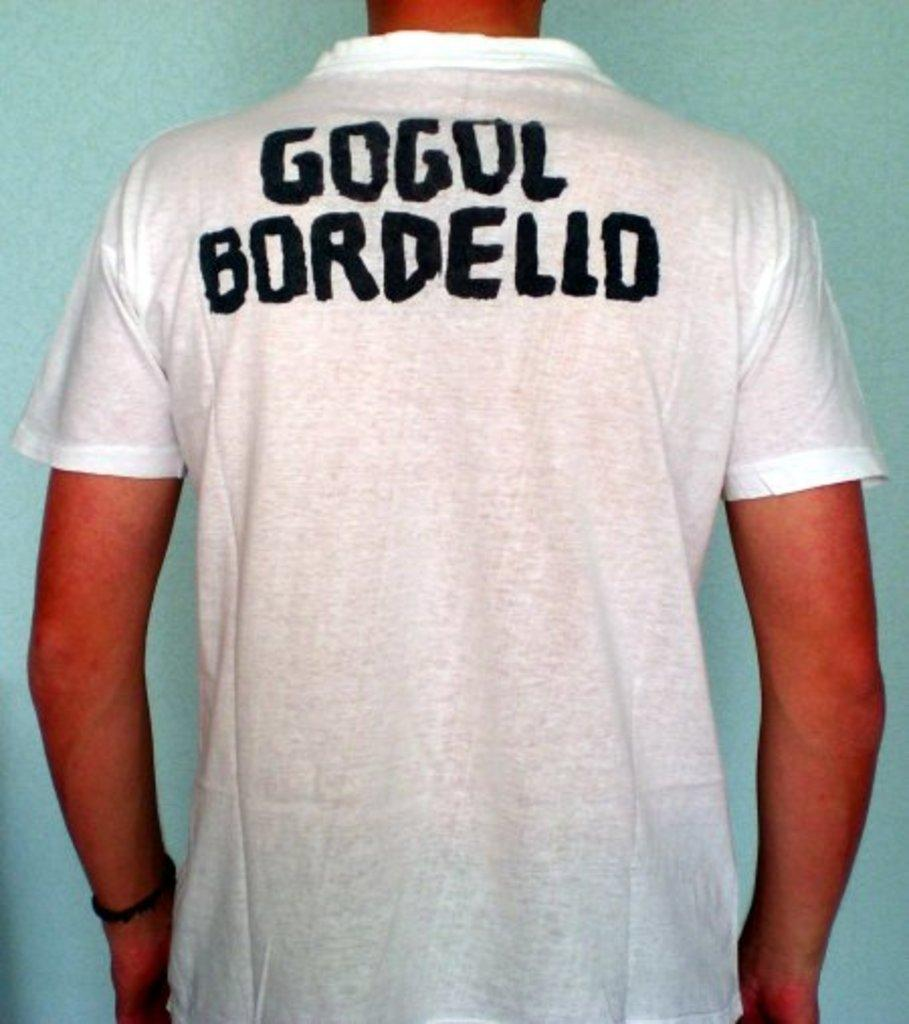<image>
Provide a brief description of the given image. A person is facing away from the camera to show the back of a white tshirt that says Gogol Bordello. 